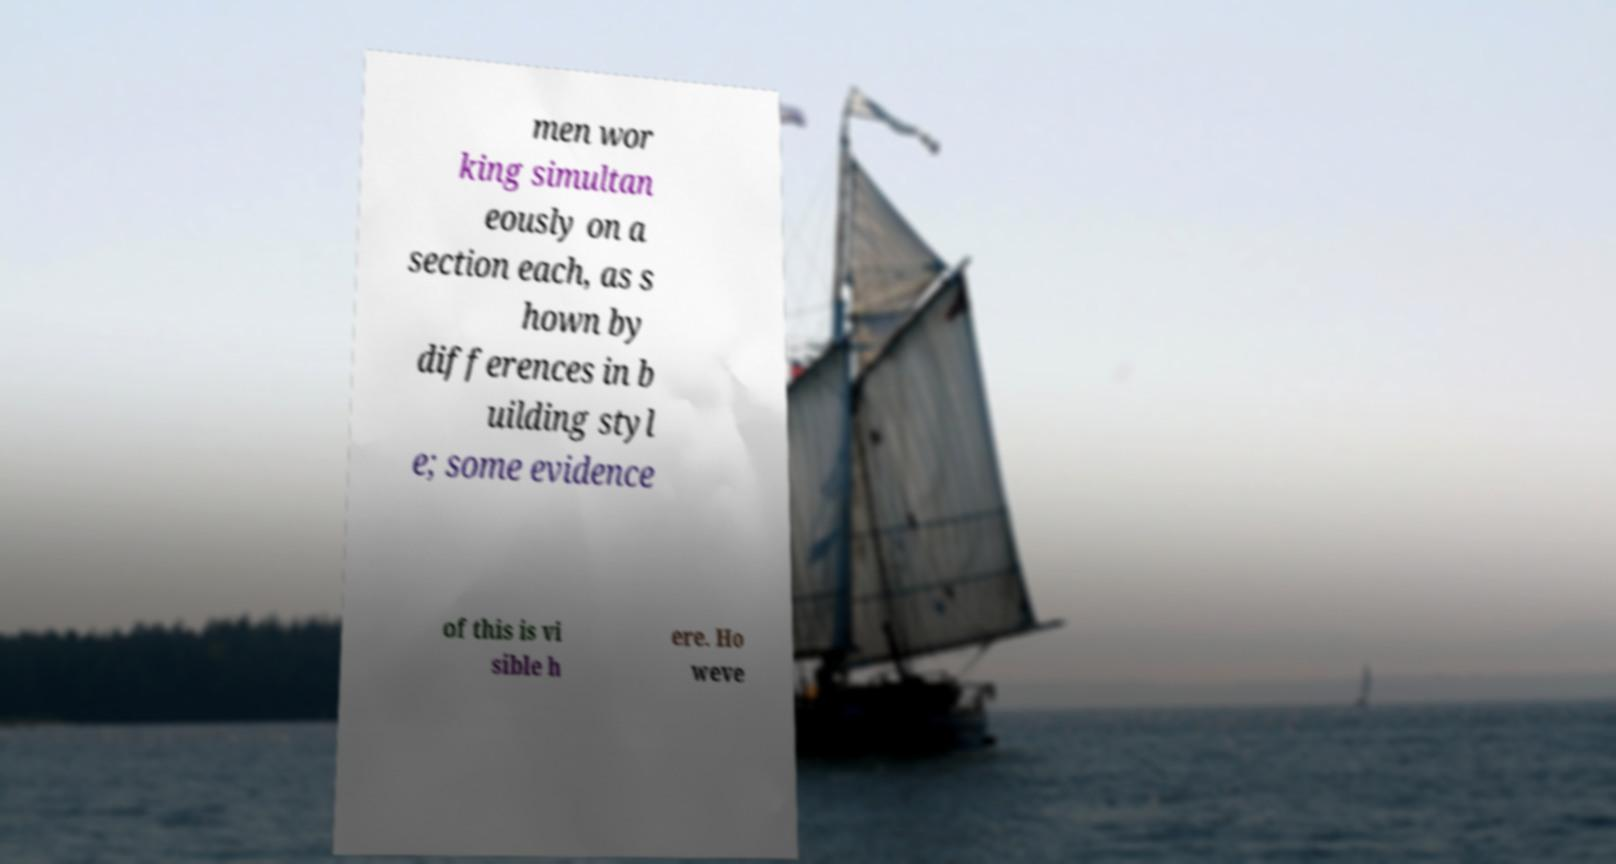Could you extract and type out the text from this image? men wor king simultan eously on a section each, as s hown by differences in b uilding styl e; some evidence of this is vi sible h ere. Ho weve 